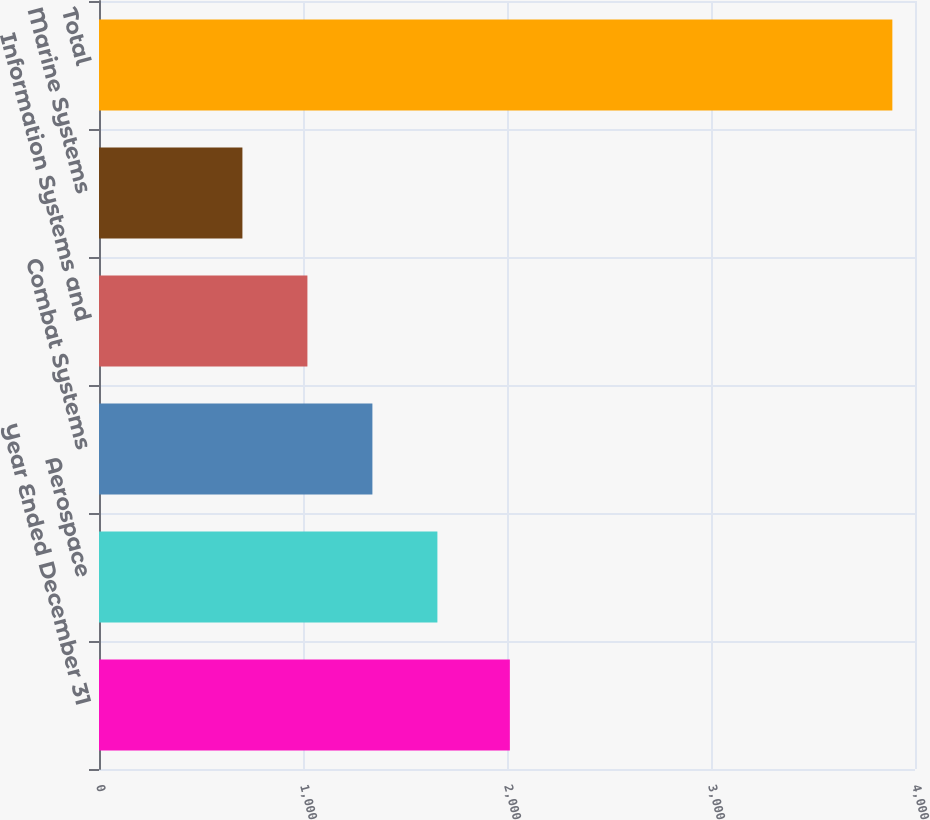Convert chart to OTSL. <chart><loc_0><loc_0><loc_500><loc_500><bar_chart><fcel>Year Ended December 31<fcel>Aerospace<fcel>Combat Systems<fcel>Information Systems and<fcel>Marine Systems<fcel>Total<nl><fcel>2014<fcel>1658.8<fcel>1340.2<fcel>1021.6<fcel>703<fcel>3889<nl></chart> 